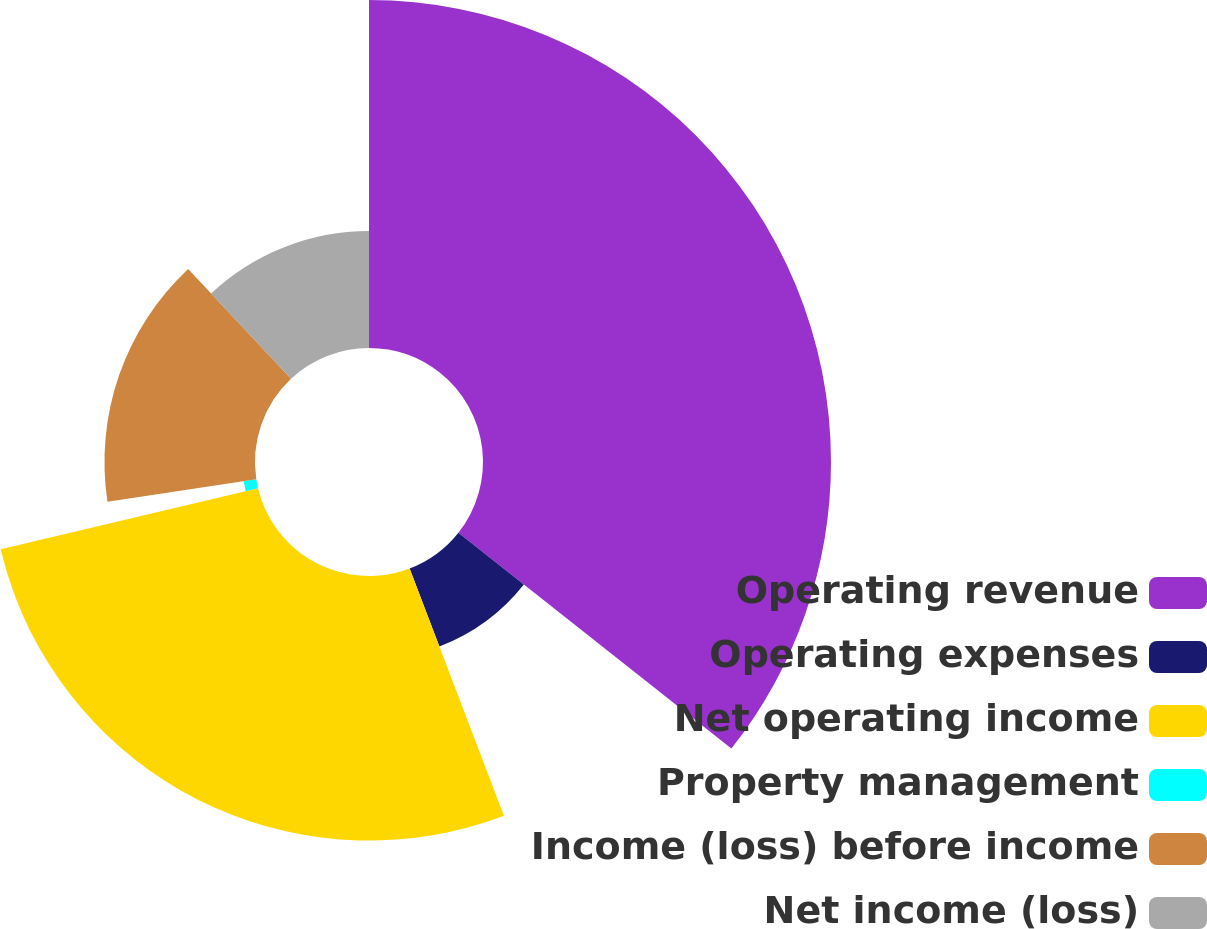Convert chart. <chart><loc_0><loc_0><loc_500><loc_500><pie_chart><fcel>Operating revenue<fcel>Operating expenses<fcel>Net operating income<fcel>Property management<fcel>Income (loss) before income<fcel>Net income (loss)<nl><fcel>35.65%<fcel>8.55%<fcel>27.1%<fcel>1.3%<fcel>15.42%<fcel>11.98%<nl></chart> 